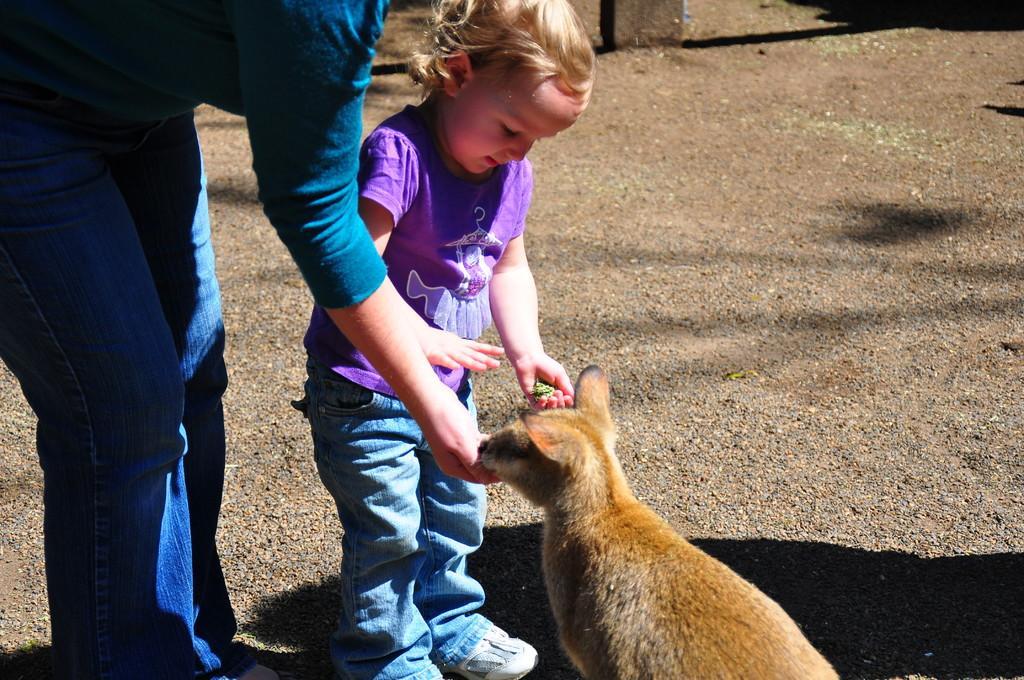Describe this image in one or two sentences. In this image i can see a woman stand and wearing a blue color jeans pant and beside her a baby girl she is wearing a brinjal color t-shirt and she holding some food. and give it to the cat. cat stand the middle of the image. 